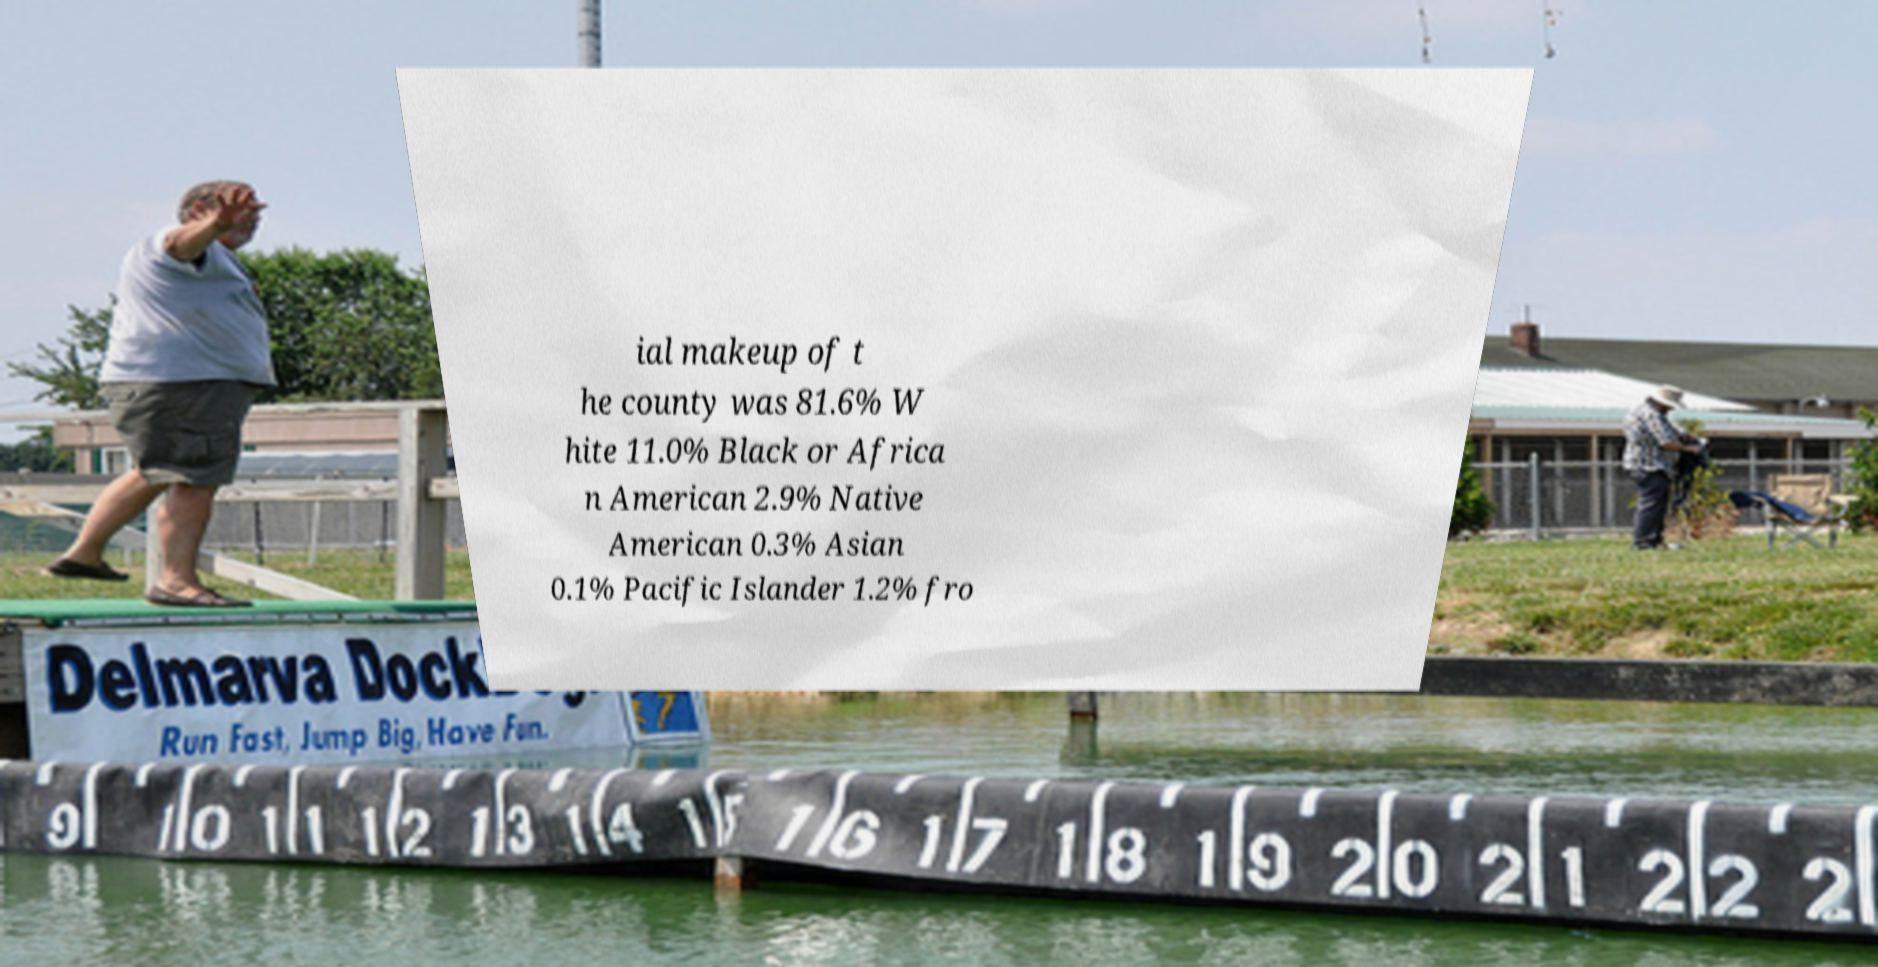Could you extract and type out the text from this image? ial makeup of t he county was 81.6% W hite 11.0% Black or Africa n American 2.9% Native American 0.3% Asian 0.1% Pacific Islander 1.2% fro 